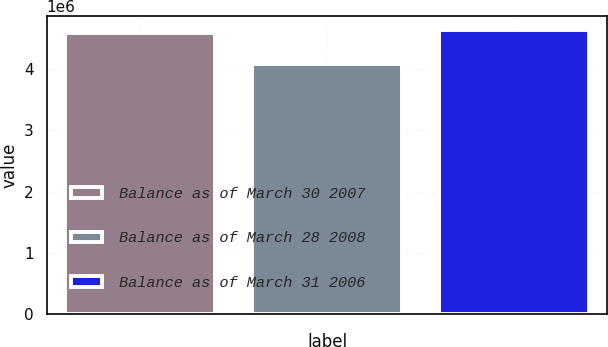<chart> <loc_0><loc_0><loc_500><loc_500><bar_chart><fcel>Balance as of March 30 2007<fcel>Balance as of March 28 2008<fcel>Balance as of March 31 2006<nl><fcel>4.58207e+06<fcel>4.08072e+06<fcel>4.63379e+06<nl></chart> 